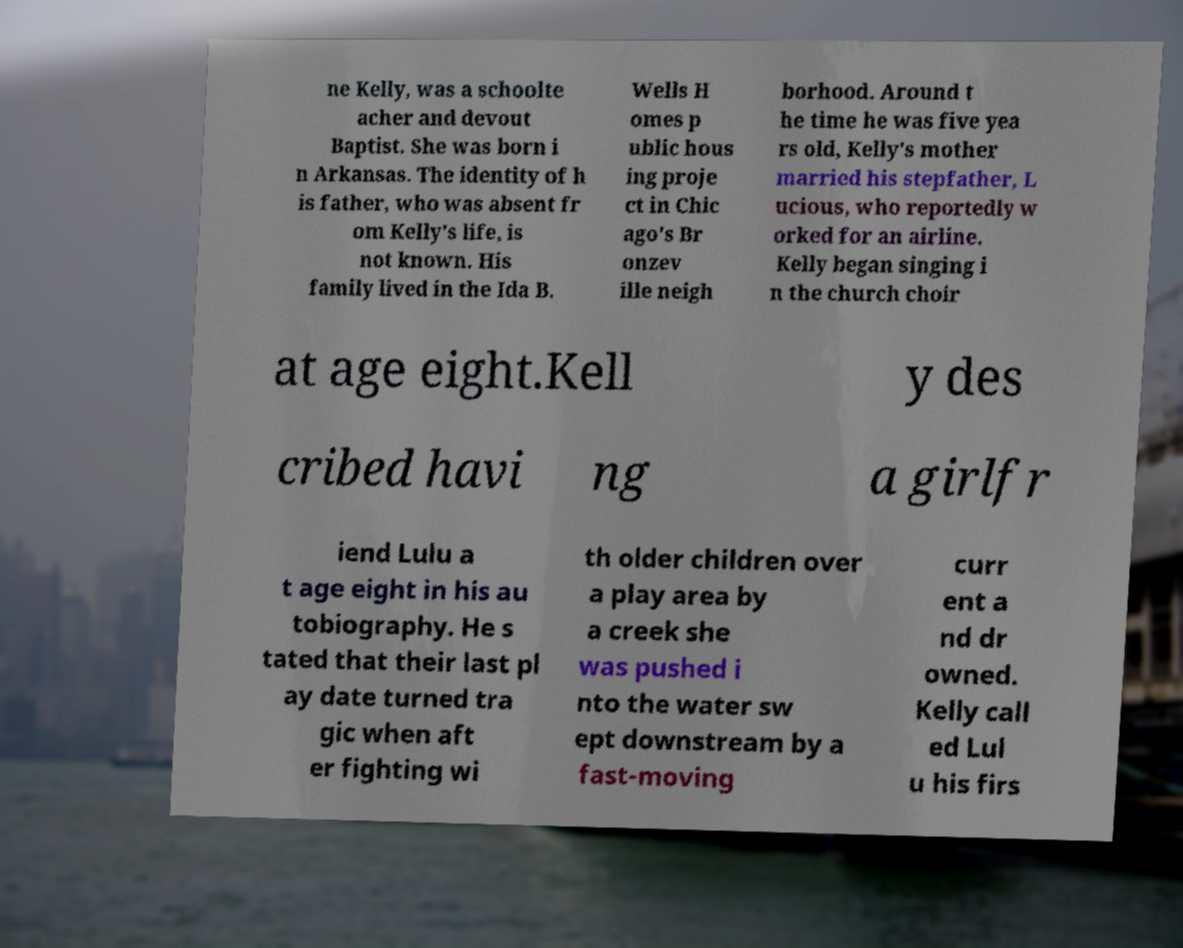Could you assist in decoding the text presented in this image and type it out clearly? ne Kelly, was a schoolte acher and devout Baptist. She was born i n Arkansas. The identity of h is father, who was absent fr om Kelly's life, is not known. His family lived in the Ida B. Wells H omes p ublic hous ing proje ct in Chic ago's Br onzev ille neigh borhood. Around t he time he was five yea rs old, Kelly's mother married his stepfather, L ucious, who reportedly w orked for an airline. Kelly began singing i n the church choir at age eight.Kell y des cribed havi ng a girlfr iend Lulu a t age eight in his au tobiography. He s tated that their last pl ay date turned tra gic when aft er fighting wi th older children over a play area by a creek she was pushed i nto the water sw ept downstream by a fast-moving curr ent a nd dr owned. Kelly call ed Lul u his firs 